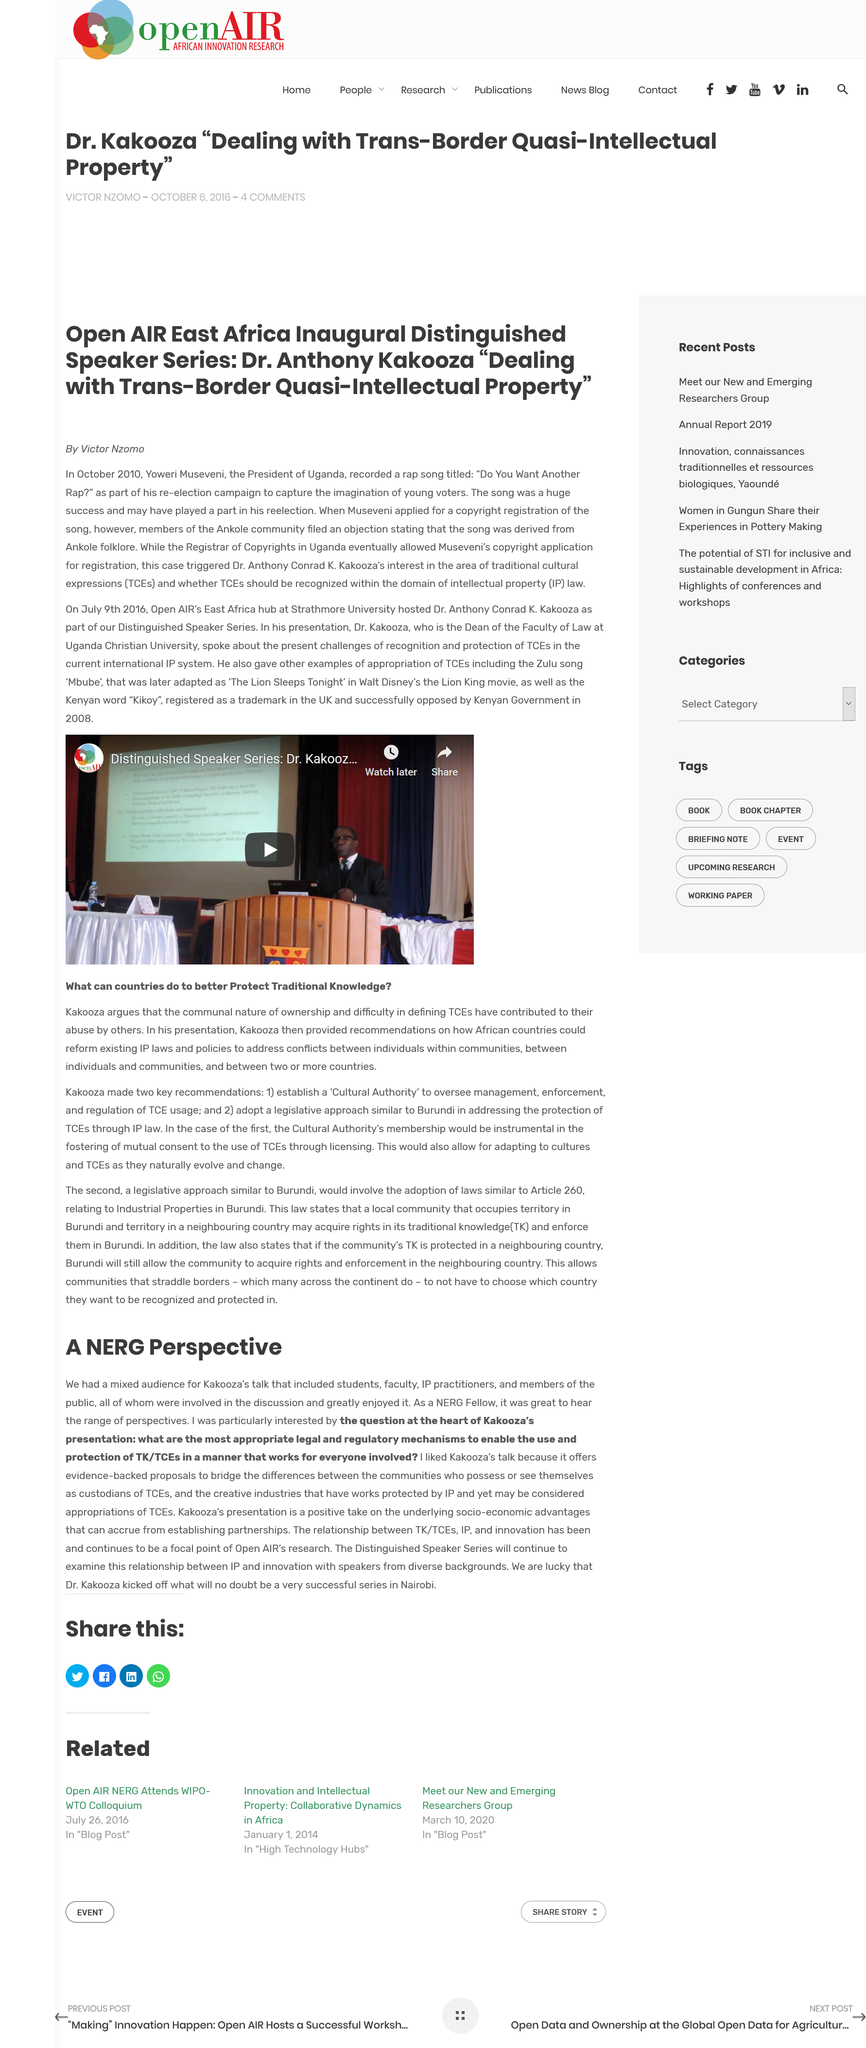Indicate a few pertinent items in this graphic. The full name of the Doctor mentioned in the article is Dr. Anthony Conrad K. Kakooza. The article's author is Victor Nzomo. The title of the rap song recorded by the President of Uganda in October 2010 was "Do You Want Another Rap?... 